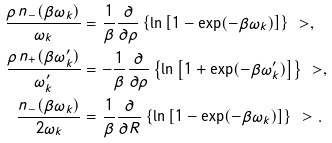Convert formula to latex. <formula><loc_0><loc_0><loc_500><loc_500>\frac { \rho \, n _ { - } ( \beta \omega _ { k } ) } { \omega _ { k } } & = \frac { 1 } { \beta } \frac { \partial } { \partial \rho } \left \{ \ln \left [ 1 - \exp ( - \beta \omega _ { k } ) \right ] \right \} \ > , \\ \frac { \rho \, n _ { + } ( \beta \omega ^ { \prime } _ { k } ) } { \omega ^ { \prime } _ { k } } & = - \frac { 1 } { \beta } \frac { \partial } { \partial \rho } \left \{ \ln \left [ 1 + \exp ( - \beta \omega ^ { \prime } _ { k } ) \right ] \right \} \ > , \\ \frac { n _ { - } ( \beta \omega _ { k } ) } { 2 \omega _ { k } } & = \frac { 1 } { \beta } \frac { \partial } { \partial R } \left \{ \ln \left [ 1 - \exp ( - \beta \omega _ { k } ) \right ] \right \} \ > .</formula> 